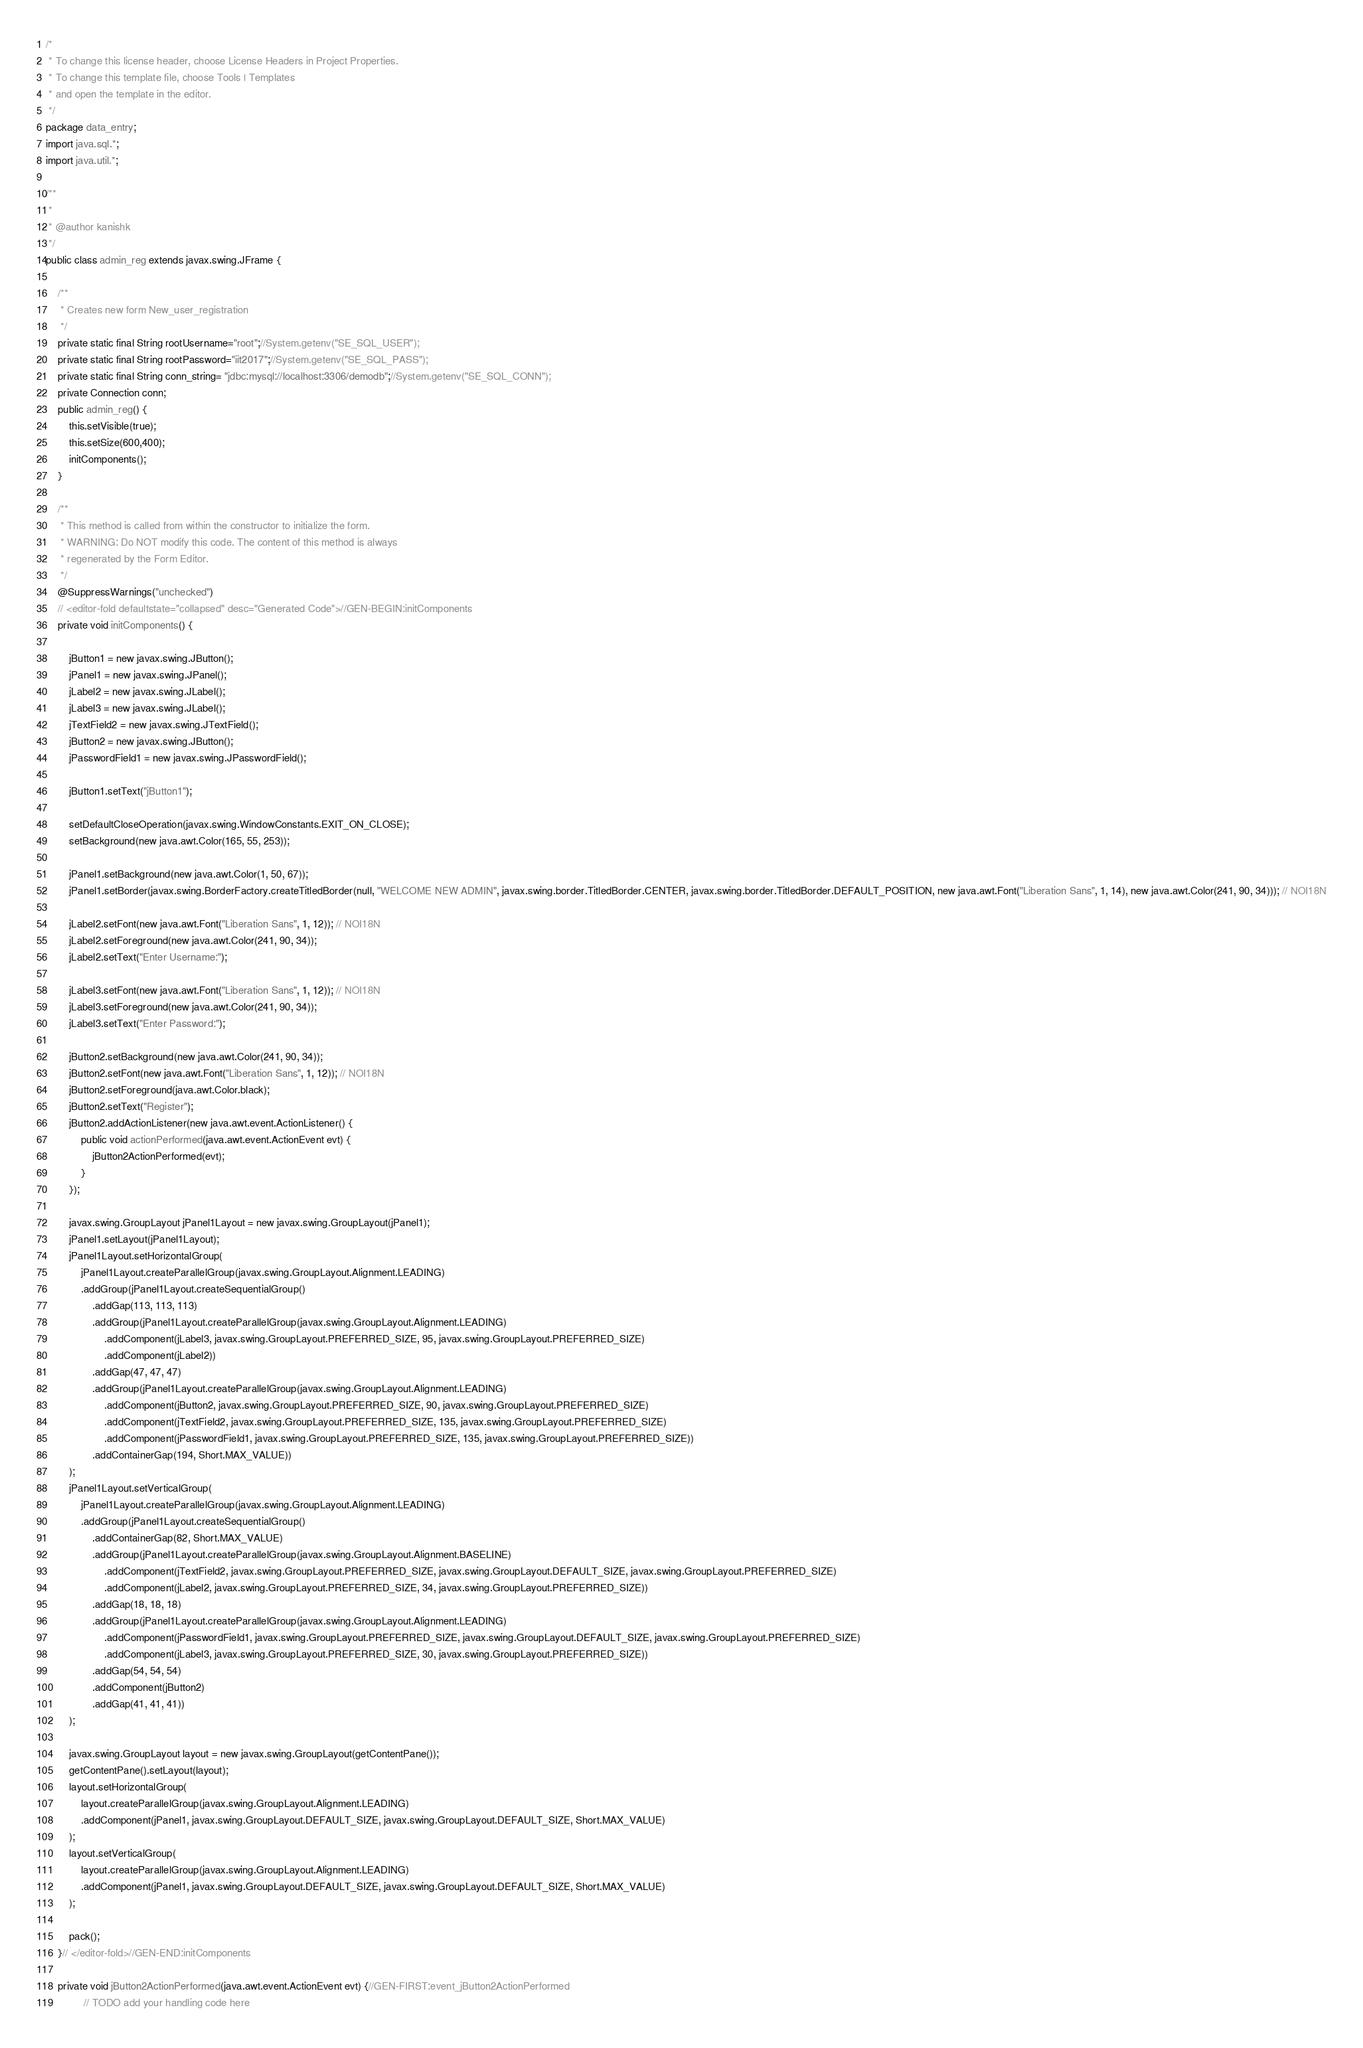<code> <loc_0><loc_0><loc_500><loc_500><_Java_>/*
 * To change this license header, choose License Headers in Project Properties.
 * To change this template file, choose Tools | Templates
 * and open the template in the editor.
 */
package data_entry;
import java.sql.*;
import java.util.*;

/**
 *
 * @author kanishk
 */
public class admin_reg extends javax.swing.JFrame {

    /**
     * Creates new form New_user_registration
     */
    private static final String rootUsername="root";//System.getenv("SE_SQL_USER");
    private static final String rootPassword="iit2017";//System.getenv("SE_SQL_PASS");
    private static final String conn_string= "jdbc:mysql://localhost:3306/demodb";//System.getenv("SE_SQL_CONN");
    private Connection conn;
    public admin_reg() {
        this.setVisible(true);
        this.setSize(600,400);
        initComponents();
    }

    /**
     * This method is called from within the constructor to initialize the form.
     * WARNING: Do NOT modify this code. The content of this method is always
     * regenerated by the Form Editor.
     */
    @SuppressWarnings("unchecked")
    // <editor-fold defaultstate="collapsed" desc="Generated Code">//GEN-BEGIN:initComponents
    private void initComponents() {

        jButton1 = new javax.swing.JButton();
        jPanel1 = new javax.swing.JPanel();
        jLabel2 = new javax.swing.JLabel();
        jLabel3 = new javax.swing.JLabel();
        jTextField2 = new javax.swing.JTextField();
        jButton2 = new javax.swing.JButton();
        jPasswordField1 = new javax.swing.JPasswordField();

        jButton1.setText("jButton1");

        setDefaultCloseOperation(javax.swing.WindowConstants.EXIT_ON_CLOSE);
        setBackground(new java.awt.Color(165, 55, 253));

        jPanel1.setBackground(new java.awt.Color(1, 50, 67));
        jPanel1.setBorder(javax.swing.BorderFactory.createTitledBorder(null, "WELCOME NEW ADMIN", javax.swing.border.TitledBorder.CENTER, javax.swing.border.TitledBorder.DEFAULT_POSITION, new java.awt.Font("Liberation Sans", 1, 14), new java.awt.Color(241, 90, 34))); // NOI18N

        jLabel2.setFont(new java.awt.Font("Liberation Sans", 1, 12)); // NOI18N
        jLabel2.setForeground(new java.awt.Color(241, 90, 34));
        jLabel2.setText("Enter Username:");

        jLabel3.setFont(new java.awt.Font("Liberation Sans", 1, 12)); // NOI18N
        jLabel3.setForeground(new java.awt.Color(241, 90, 34));
        jLabel3.setText("Enter Password:");

        jButton2.setBackground(new java.awt.Color(241, 90, 34));
        jButton2.setFont(new java.awt.Font("Liberation Sans", 1, 12)); // NOI18N
        jButton2.setForeground(java.awt.Color.black);
        jButton2.setText("Register");
        jButton2.addActionListener(new java.awt.event.ActionListener() {
            public void actionPerformed(java.awt.event.ActionEvent evt) {
                jButton2ActionPerformed(evt);
            }
        });

        javax.swing.GroupLayout jPanel1Layout = new javax.swing.GroupLayout(jPanel1);
        jPanel1.setLayout(jPanel1Layout);
        jPanel1Layout.setHorizontalGroup(
            jPanel1Layout.createParallelGroup(javax.swing.GroupLayout.Alignment.LEADING)
            .addGroup(jPanel1Layout.createSequentialGroup()
                .addGap(113, 113, 113)
                .addGroup(jPanel1Layout.createParallelGroup(javax.swing.GroupLayout.Alignment.LEADING)
                    .addComponent(jLabel3, javax.swing.GroupLayout.PREFERRED_SIZE, 95, javax.swing.GroupLayout.PREFERRED_SIZE)
                    .addComponent(jLabel2))
                .addGap(47, 47, 47)
                .addGroup(jPanel1Layout.createParallelGroup(javax.swing.GroupLayout.Alignment.LEADING)
                    .addComponent(jButton2, javax.swing.GroupLayout.PREFERRED_SIZE, 90, javax.swing.GroupLayout.PREFERRED_SIZE)
                    .addComponent(jTextField2, javax.swing.GroupLayout.PREFERRED_SIZE, 135, javax.swing.GroupLayout.PREFERRED_SIZE)
                    .addComponent(jPasswordField1, javax.swing.GroupLayout.PREFERRED_SIZE, 135, javax.swing.GroupLayout.PREFERRED_SIZE))
                .addContainerGap(194, Short.MAX_VALUE))
        );
        jPanel1Layout.setVerticalGroup(
            jPanel1Layout.createParallelGroup(javax.swing.GroupLayout.Alignment.LEADING)
            .addGroup(jPanel1Layout.createSequentialGroup()
                .addContainerGap(82, Short.MAX_VALUE)
                .addGroup(jPanel1Layout.createParallelGroup(javax.swing.GroupLayout.Alignment.BASELINE)
                    .addComponent(jTextField2, javax.swing.GroupLayout.PREFERRED_SIZE, javax.swing.GroupLayout.DEFAULT_SIZE, javax.swing.GroupLayout.PREFERRED_SIZE)
                    .addComponent(jLabel2, javax.swing.GroupLayout.PREFERRED_SIZE, 34, javax.swing.GroupLayout.PREFERRED_SIZE))
                .addGap(18, 18, 18)
                .addGroup(jPanel1Layout.createParallelGroup(javax.swing.GroupLayout.Alignment.LEADING)
                    .addComponent(jPasswordField1, javax.swing.GroupLayout.PREFERRED_SIZE, javax.swing.GroupLayout.DEFAULT_SIZE, javax.swing.GroupLayout.PREFERRED_SIZE)
                    .addComponent(jLabel3, javax.swing.GroupLayout.PREFERRED_SIZE, 30, javax.swing.GroupLayout.PREFERRED_SIZE))
                .addGap(54, 54, 54)
                .addComponent(jButton2)
                .addGap(41, 41, 41))
        );

        javax.swing.GroupLayout layout = new javax.swing.GroupLayout(getContentPane());
        getContentPane().setLayout(layout);
        layout.setHorizontalGroup(
            layout.createParallelGroup(javax.swing.GroupLayout.Alignment.LEADING)
            .addComponent(jPanel1, javax.swing.GroupLayout.DEFAULT_SIZE, javax.swing.GroupLayout.DEFAULT_SIZE, Short.MAX_VALUE)
        );
        layout.setVerticalGroup(
            layout.createParallelGroup(javax.swing.GroupLayout.Alignment.LEADING)
            .addComponent(jPanel1, javax.swing.GroupLayout.DEFAULT_SIZE, javax.swing.GroupLayout.DEFAULT_SIZE, Short.MAX_VALUE)
        );

        pack();
    }// </editor-fold>//GEN-END:initComponents

    private void jButton2ActionPerformed(java.awt.event.ActionEvent evt) {//GEN-FIRST:event_jButton2ActionPerformed
             // TODO add your handling code here</code> 